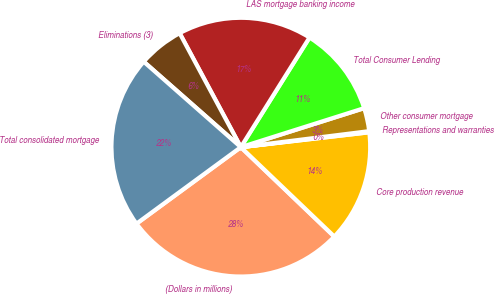Convert chart. <chart><loc_0><loc_0><loc_500><loc_500><pie_chart><fcel>(Dollars in millions)<fcel>Core production revenue<fcel>Representations and warranties<fcel>Other consumer mortgage<fcel>Total Consumer Lending<fcel>LAS mortgage banking income<fcel>Eliminations (3)<fcel>Total consolidated mortgage<nl><fcel>27.79%<fcel>13.98%<fcel>0.14%<fcel>2.9%<fcel>11.22%<fcel>16.75%<fcel>5.67%<fcel>21.56%<nl></chart> 